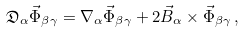Convert formula to latex. <formula><loc_0><loc_0><loc_500><loc_500>\mathfrak { D } _ { \alpha } \vec { \Phi } _ { \beta \gamma } = \nabla _ { \alpha } \vec { \Phi } _ { \beta \gamma } + 2 \vec { B } _ { \alpha } \times \vec { \Phi } _ { \beta \gamma } \, ,</formula> 